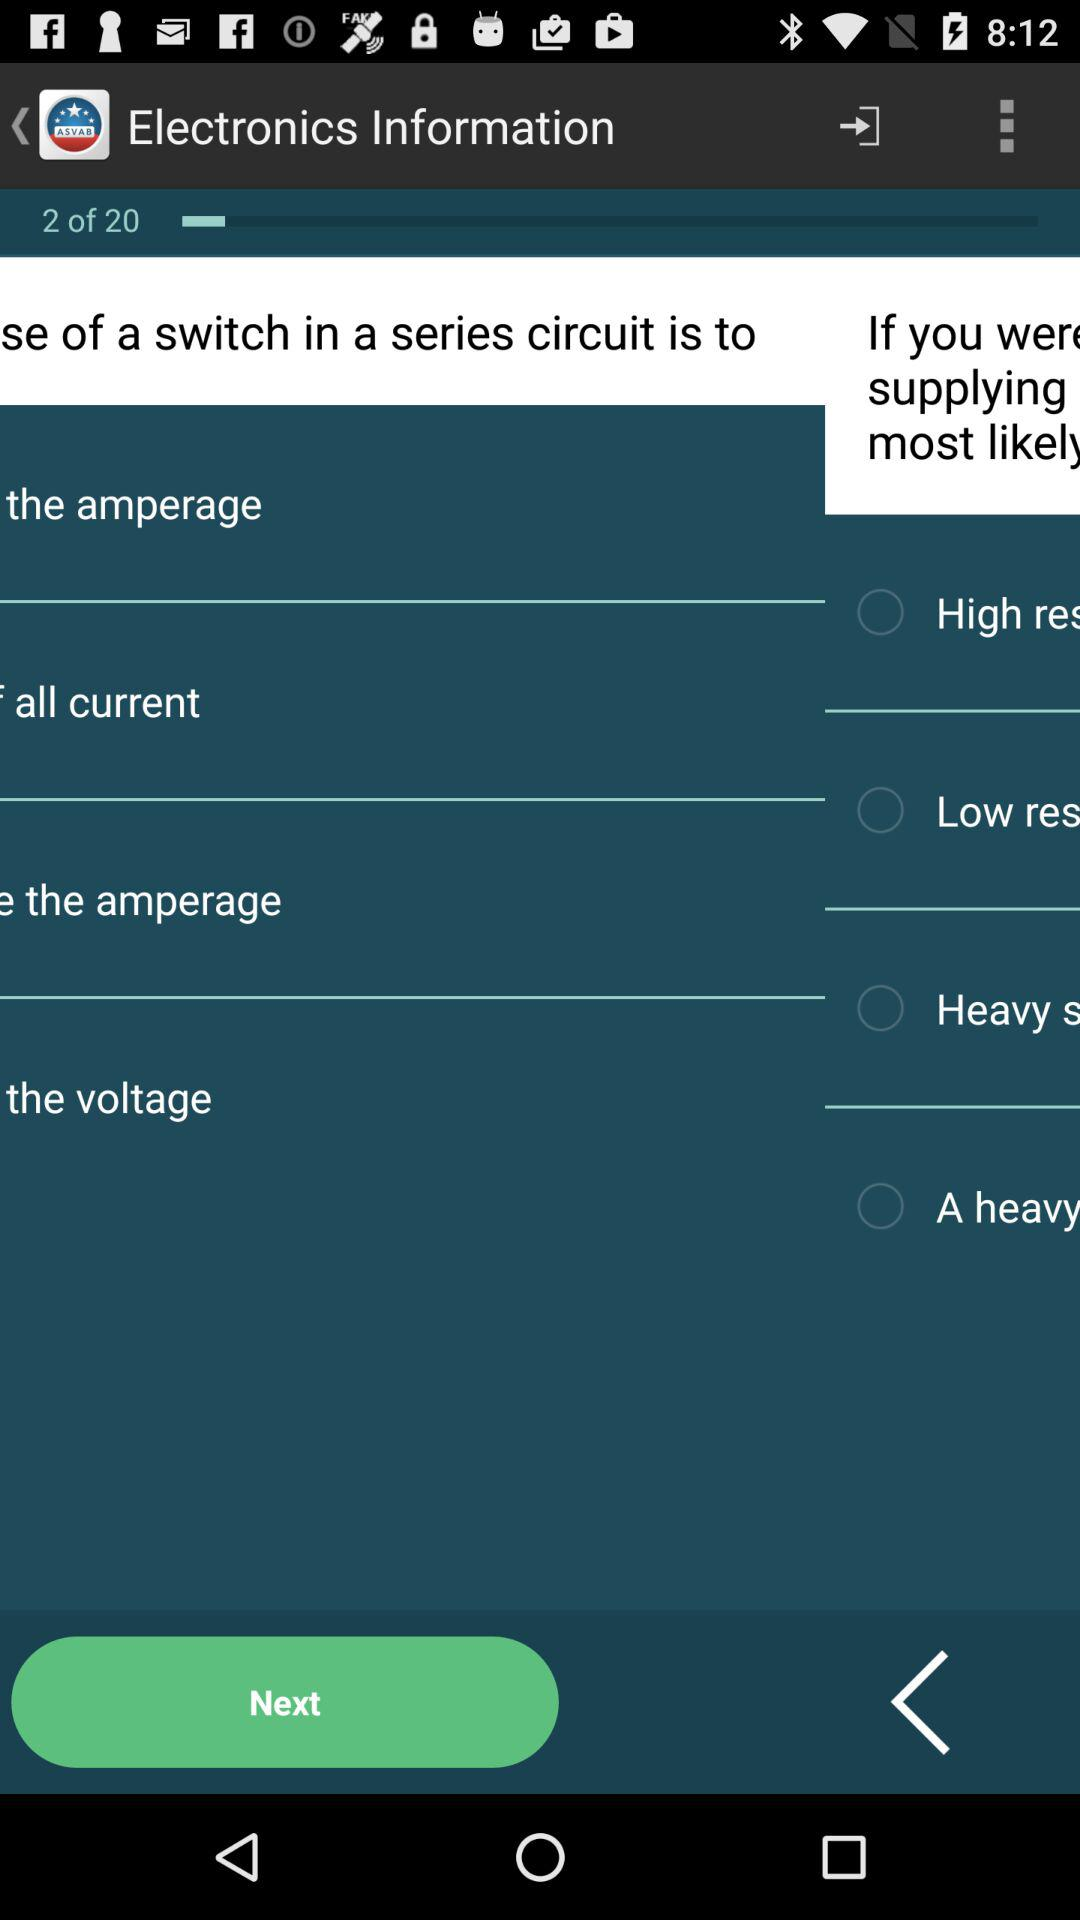On which page number currently are we on? We are currently on page number 2. 